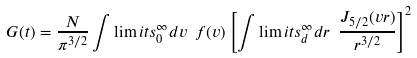<formula> <loc_0><loc_0><loc_500><loc_500>G ( t ) = \frac { N } { \pi ^ { 3 / 2 } } \int \lim i t s _ { 0 } ^ { \infty } d v \ f ( v ) \left [ \int \lim i t s _ { d } ^ { \infty } d r \ \frac { J _ { 5 / 2 } ( v r ) } { r ^ { 3 / 2 } } \right ] ^ { 2 }</formula> 